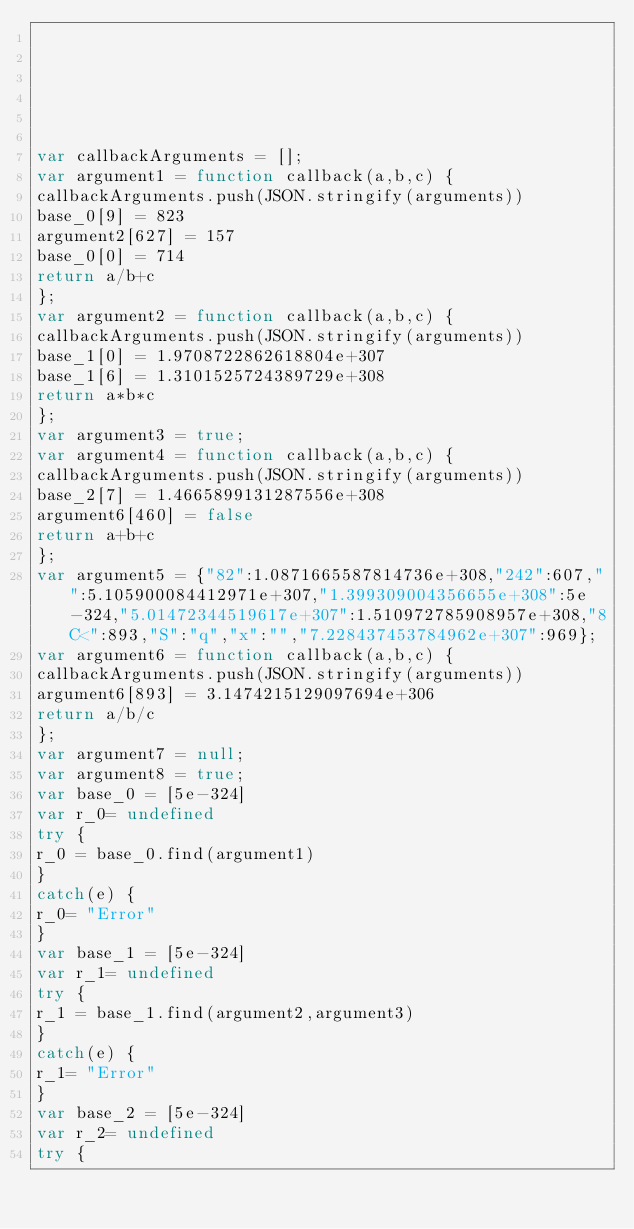<code> <loc_0><loc_0><loc_500><loc_500><_JavaScript_>





var callbackArguments = [];
var argument1 = function callback(a,b,c) { 
callbackArguments.push(JSON.stringify(arguments))
base_0[9] = 823
argument2[627] = 157
base_0[0] = 714
return a/b+c
};
var argument2 = function callback(a,b,c) { 
callbackArguments.push(JSON.stringify(arguments))
base_1[0] = 1.9708722862618804e+307
base_1[6] = 1.3101525724389729e+308
return a*b*c
};
var argument3 = true;
var argument4 = function callback(a,b,c) { 
callbackArguments.push(JSON.stringify(arguments))
base_2[7] = 1.4665899131287556e+308
argument6[460] = false
return a+b+c
};
var argument5 = {"82":1.0871665587814736e+308,"242":607,"":5.105900084412971e+307,"1.399309004356655e+308":5e-324,"5.01472344519617e+307":1.510972785908957e+308,"8C<":893,"S":"q","x":"","7.228437453784962e+307":969};
var argument6 = function callback(a,b,c) { 
callbackArguments.push(JSON.stringify(arguments))
argument6[893] = 3.1474215129097694e+306
return a/b/c
};
var argument7 = null;
var argument8 = true;
var base_0 = [5e-324]
var r_0= undefined
try {
r_0 = base_0.find(argument1)
}
catch(e) {
r_0= "Error"
}
var base_1 = [5e-324]
var r_1= undefined
try {
r_1 = base_1.find(argument2,argument3)
}
catch(e) {
r_1= "Error"
}
var base_2 = [5e-324]
var r_2= undefined
try {</code> 